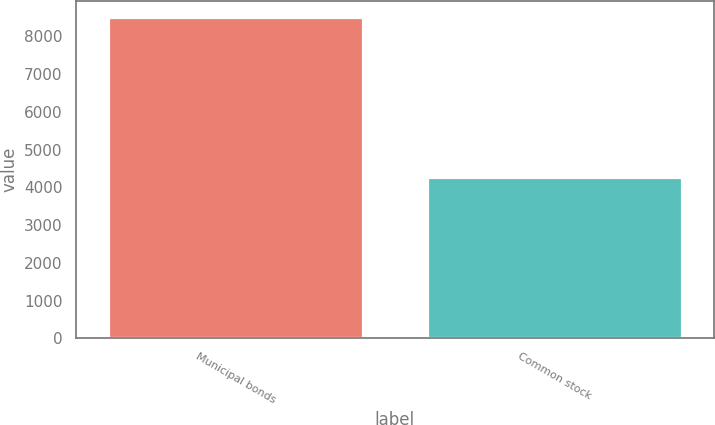Convert chart to OTSL. <chart><loc_0><loc_0><loc_500><loc_500><bar_chart><fcel>Municipal bonds<fcel>Common stock<nl><fcel>8508<fcel>4280<nl></chart> 